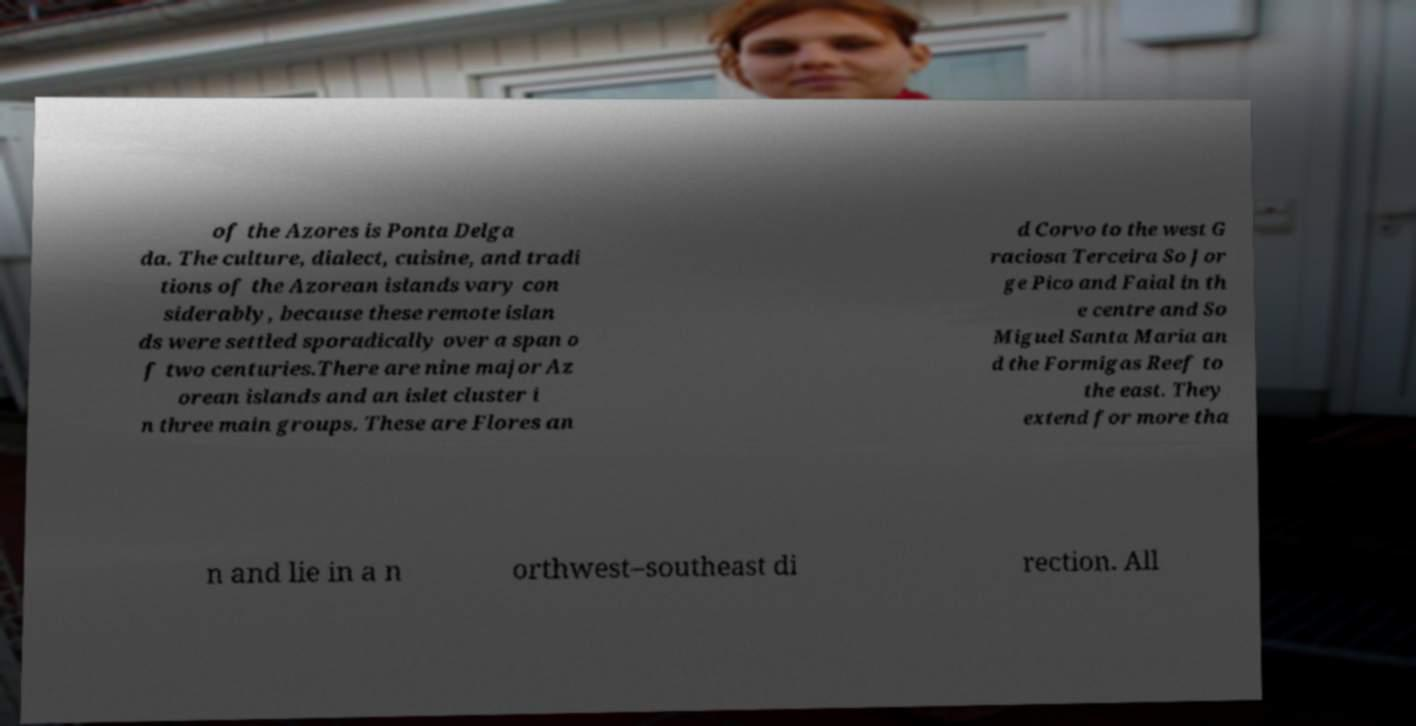What messages or text are displayed in this image? I need them in a readable, typed format. of the Azores is Ponta Delga da. The culture, dialect, cuisine, and tradi tions of the Azorean islands vary con siderably, because these remote islan ds were settled sporadically over a span o f two centuries.There are nine major Az orean islands and an islet cluster i n three main groups. These are Flores an d Corvo to the west G raciosa Terceira So Jor ge Pico and Faial in th e centre and So Miguel Santa Maria an d the Formigas Reef to the east. They extend for more tha n and lie in a n orthwest–southeast di rection. All 